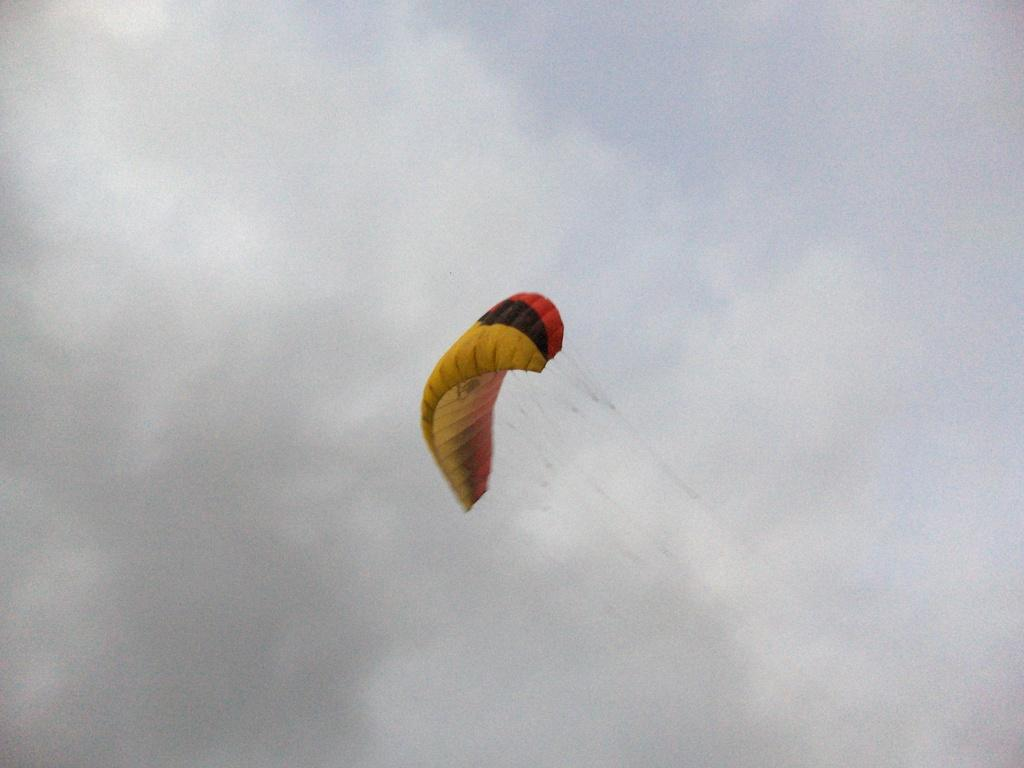What is the main object in the middle of the image? There is a parachute in the middle of the image. What can be seen in the background of the image? The sky in the background is cloudy. What type of channel is visible in the image? There is no channel present in the image; it features a parachute and a cloudy sky. Is there a tent in the image? There is no tent present in the image. 